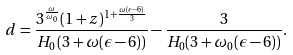Convert formula to latex. <formula><loc_0><loc_0><loc_500><loc_500>d = \frac { 3 ^ { \frac { \omega } { \omega _ { 0 } } } ( 1 + z ) ^ { 1 + \frac { \omega ( \epsilon - 6 ) } { 3 } } } { H _ { 0 } \left ( 3 + \omega ( \epsilon - 6 ) \right ) } - \frac { 3 } { H _ { 0 } ( 3 + \omega _ { 0 } ( \epsilon - 6 ) ) } .</formula> 